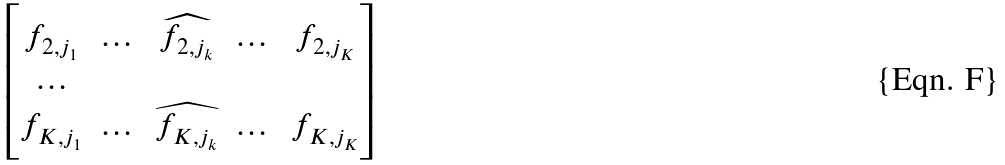Convert formula to latex. <formula><loc_0><loc_0><loc_500><loc_500>\begin{bmatrix} f _ { 2 , j _ { 1 } } & \dots & \widehat { f _ { 2 , j _ { k } } } & \dots & f _ { 2 , j _ { K } } \\ \dots \\ f _ { K , j _ { 1 } } & \dots & \widehat { f _ { K , j _ { k } } } & \dots & f _ { K , j _ { K } } \end{bmatrix}</formula> 